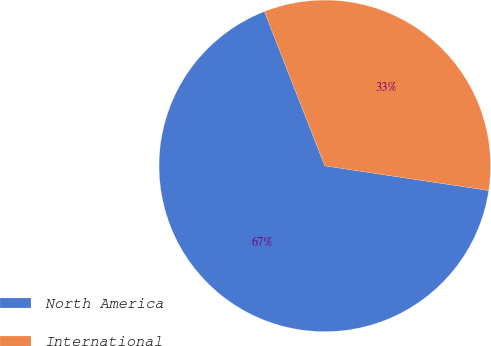Convert chart to OTSL. <chart><loc_0><loc_0><loc_500><loc_500><pie_chart><fcel>North America<fcel>International<nl><fcel>66.69%<fcel>33.31%<nl></chart> 